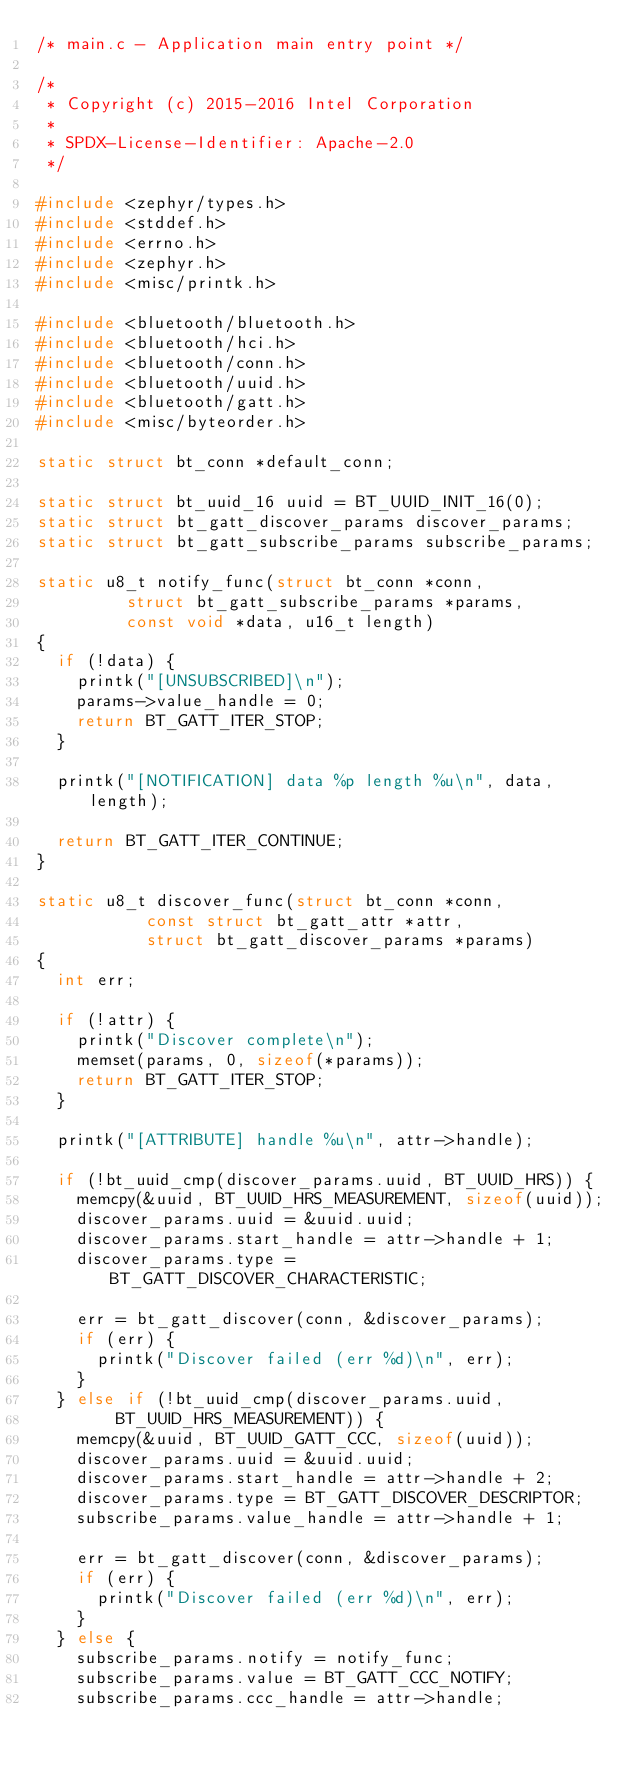<code> <loc_0><loc_0><loc_500><loc_500><_C_>/* main.c - Application main entry point */

/*
 * Copyright (c) 2015-2016 Intel Corporation
 *
 * SPDX-License-Identifier: Apache-2.0
 */

#include <zephyr/types.h>
#include <stddef.h>
#include <errno.h>
#include <zephyr.h>
#include <misc/printk.h>

#include <bluetooth/bluetooth.h>
#include <bluetooth/hci.h>
#include <bluetooth/conn.h>
#include <bluetooth/uuid.h>
#include <bluetooth/gatt.h>
#include <misc/byteorder.h>

static struct bt_conn *default_conn;

static struct bt_uuid_16 uuid = BT_UUID_INIT_16(0);
static struct bt_gatt_discover_params discover_params;
static struct bt_gatt_subscribe_params subscribe_params;

static u8_t notify_func(struct bt_conn *conn,
			   struct bt_gatt_subscribe_params *params,
			   const void *data, u16_t length)
{
	if (!data) {
		printk("[UNSUBSCRIBED]\n");
		params->value_handle = 0;
		return BT_GATT_ITER_STOP;
	}

	printk("[NOTIFICATION] data %p length %u\n", data, length);

	return BT_GATT_ITER_CONTINUE;
}

static u8_t discover_func(struct bt_conn *conn,
			     const struct bt_gatt_attr *attr,
			     struct bt_gatt_discover_params *params)
{
	int err;

	if (!attr) {
		printk("Discover complete\n");
		memset(params, 0, sizeof(*params));
		return BT_GATT_ITER_STOP;
	}

	printk("[ATTRIBUTE] handle %u\n", attr->handle);

	if (!bt_uuid_cmp(discover_params.uuid, BT_UUID_HRS)) {
		memcpy(&uuid, BT_UUID_HRS_MEASUREMENT, sizeof(uuid));
		discover_params.uuid = &uuid.uuid;
		discover_params.start_handle = attr->handle + 1;
		discover_params.type = BT_GATT_DISCOVER_CHARACTERISTIC;

		err = bt_gatt_discover(conn, &discover_params);
		if (err) {
			printk("Discover failed (err %d)\n", err);
		}
	} else if (!bt_uuid_cmp(discover_params.uuid,
				BT_UUID_HRS_MEASUREMENT)) {
		memcpy(&uuid, BT_UUID_GATT_CCC, sizeof(uuid));
		discover_params.uuid = &uuid.uuid;
		discover_params.start_handle = attr->handle + 2;
		discover_params.type = BT_GATT_DISCOVER_DESCRIPTOR;
		subscribe_params.value_handle = attr->handle + 1;

		err = bt_gatt_discover(conn, &discover_params);
		if (err) {
			printk("Discover failed (err %d)\n", err);
		}
	} else {
		subscribe_params.notify = notify_func;
		subscribe_params.value = BT_GATT_CCC_NOTIFY;
		subscribe_params.ccc_handle = attr->handle;
</code> 